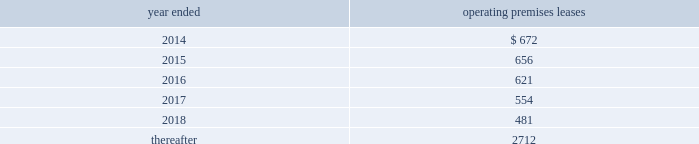Morgan stanley notes to consolidated financial statements 2014 ( continued ) lending commitments .
Primary lending commitments are those that are originated by the company whereas secondary lending commitments are purchased from third parties in the market .
The commitments include lending commitments that are made to investment grade and non-investment grade companies in connection with corporate lending and other business activities .
Commitments for secured lending transactions .
Secured lending commitments are extended by the company to companies and are secured by real estate or other physical assets of the borrower .
Loans made under these arrangements typically are at variable rates and generally provide for over-collateralization based upon the creditworthiness of the borrower .
Forward starting reverse repurchase agreements .
The company has entered into forward starting securities purchased under agreements to resell ( agreements that have a trade date at or prior to december 31 , 2013 and settle subsequent to period-end ) that are primarily secured by collateral from u.s .
Government agency securities and other sovereign government obligations .
Commercial and residential mortgage-related commitments .
The company enters into forward purchase contracts involving residential mortgage loans , residential mortgage lending commitments to individuals and residential home equity lines of credit .
In addition , the company enters into commitments to originate commercial and residential mortgage loans .
Underwriting commitments .
The company provides underwriting commitments in connection with its capital raising sources to a diverse group of corporate and other institutional clients .
Other lending commitments .
Other commitments generally include commercial lending commitments to small businesses and commitments related to securities-based lending activities in connection with the company 2019s wealth management business segment .
The company sponsors several non-consolidated investment funds for third-party investors where the company typically acts as general partner of , and investment advisor to , these funds and typically commits to invest a minority of the capital of such funds , with subscribing third-party investors contributing the majority .
The company 2019s employees , including its senior officers , as well as the company 2019s directors , may participate on the same terms and conditions as other investors in certain of these funds that the company forms primarily for client investment , except that the company may waive or lower applicable fees and charges for its employees .
The company has contractual capital commitments , guarantees , lending facilities and counterparty arrangements with respect to these investment funds .
Premises and equipment .
The company has non-cancelable operating leases covering premises and equipment ( excluding commodities operating leases , shown separately ) .
At december 31 , 2013 , future minimum rental commitments under such leases ( net of subleases , principally on office rentals ) were as follows ( dollars in millions ) : year ended operating premises leases .

What was the increase in lease liability between 2014 and 2015? 
Computations: (672 - 656)
Answer: 16.0. 